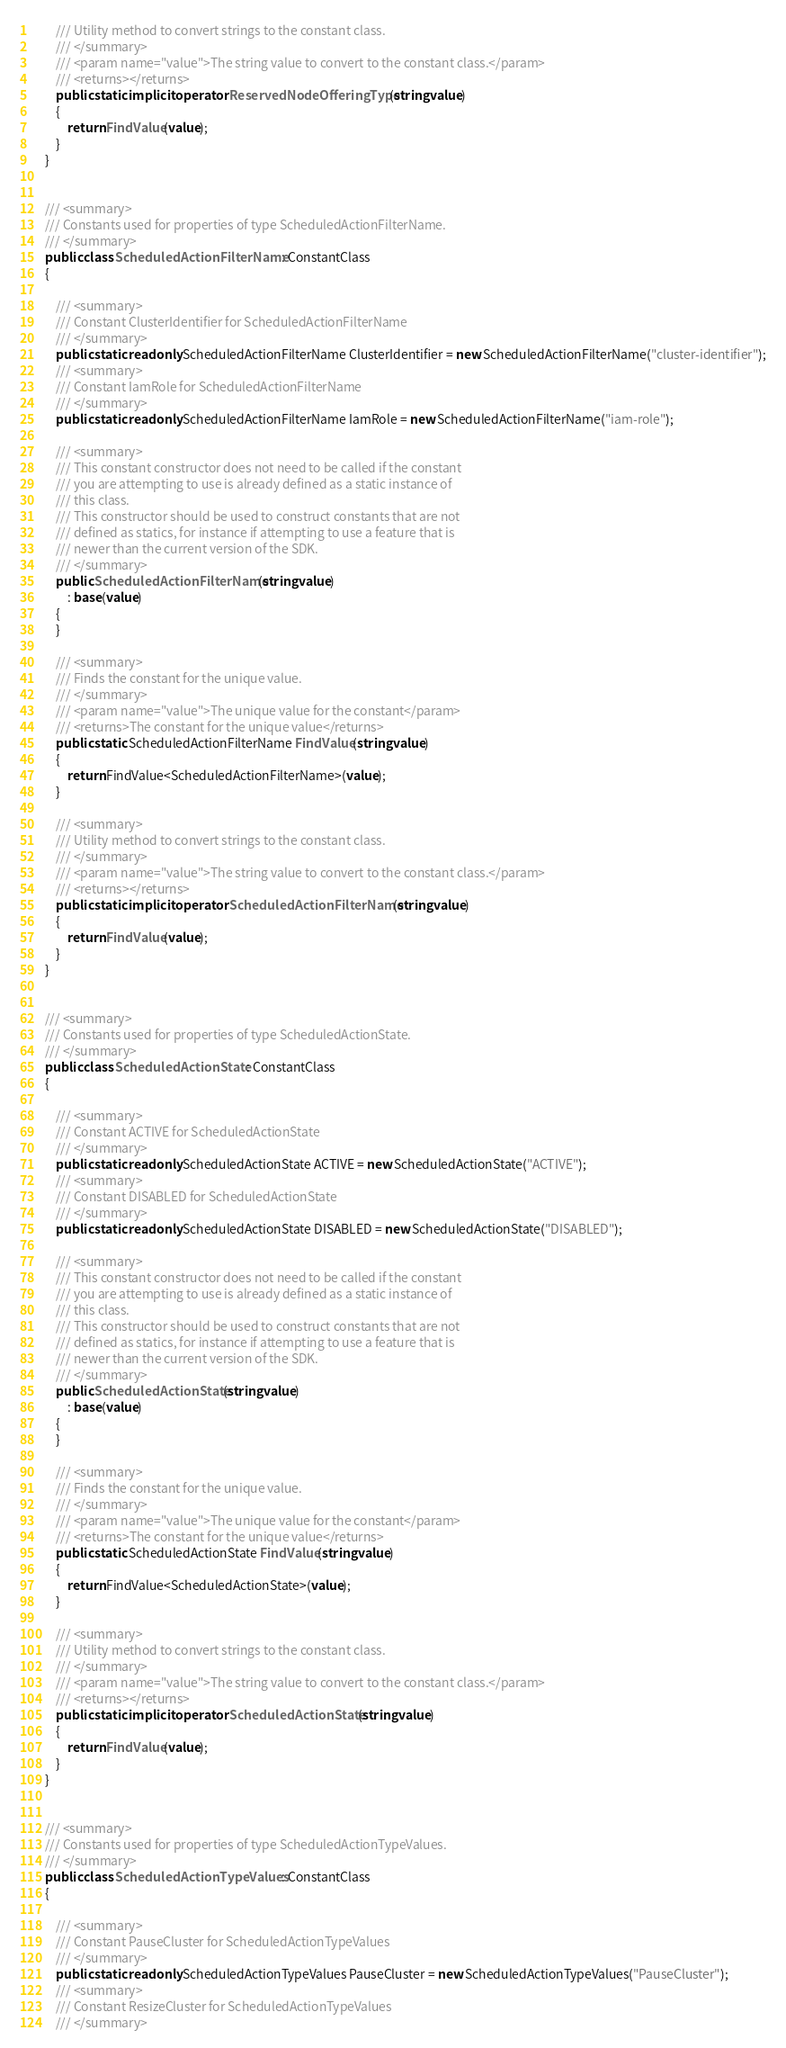<code> <loc_0><loc_0><loc_500><loc_500><_C#_>        /// Utility method to convert strings to the constant class.
        /// </summary>
        /// <param name="value">The string value to convert to the constant class.</param>
        /// <returns></returns>
        public static implicit operator ReservedNodeOfferingType(string value)
        {
            return FindValue(value);
        }
    }


    /// <summary>
    /// Constants used for properties of type ScheduledActionFilterName.
    /// </summary>
    public class ScheduledActionFilterName : ConstantClass
    {

        /// <summary>
        /// Constant ClusterIdentifier for ScheduledActionFilterName
        /// </summary>
        public static readonly ScheduledActionFilterName ClusterIdentifier = new ScheduledActionFilterName("cluster-identifier");
        /// <summary>
        /// Constant IamRole for ScheduledActionFilterName
        /// </summary>
        public static readonly ScheduledActionFilterName IamRole = new ScheduledActionFilterName("iam-role");

        /// <summary>
        /// This constant constructor does not need to be called if the constant
        /// you are attempting to use is already defined as a static instance of 
        /// this class.
        /// This constructor should be used to construct constants that are not
        /// defined as statics, for instance if attempting to use a feature that is
        /// newer than the current version of the SDK.
        /// </summary>
        public ScheduledActionFilterName(string value)
            : base(value)
        {
        }

        /// <summary>
        /// Finds the constant for the unique value.
        /// </summary>
        /// <param name="value">The unique value for the constant</param>
        /// <returns>The constant for the unique value</returns>
        public static ScheduledActionFilterName FindValue(string value)
        {
            return FindValue<ScheduledActionFilterName>(value);
        }

        /// <summary>
        /// Utility method to convert strings to the constant class.
        /// </summary>
        /// <param name="value">The string value to convert to the constant class.</param>
        /// <returns></returns>
        public static implicit operator ScheduledActionFilterName(string value)
        {
            return FindValue(value);
        }
    }


    /// <summary>
    /// Constants used for properties of type ScheduledActionState.
    /// </summary>
    public class ScheduledActionState : ConstantClass
    {

        /// <summary>
        /// Constant ACTIVE for ScheduledActionState
        /// </summary>
        public static readonly ScheduledActionState ACTIVE = new ScheduledActionState("ACTIVE");
        /// <summary>
        /// Constant DISABLED for ScheduledActionState
        /// </summary>
        public static readonly ScheduledActionState DISABLED = new ScheduledActionState("DISABLED");

        /// <summary>
        /// This constant constructor does not need to be called if the constant
        /// you are attempting to use is already defined as a static instance of 
        /// this class.
        /// This constructor should be used to construct constants that are not
        /// defined as statics, for instance if attempting to use a feature that is
        /// newer than the current version of the SDK.
        /// </summary>
        public ScheduledActionState(string value)
            : base(value)
        {
        }

        /// <summary>
        /// Finds the constant for the unique value.
        /// </summary>
        /// <param name="value">The unique value for the constant</param>
        /// <returns>The constant for the unique value</returns>
        public static ScheduledActionState FindValue(string value)
        {
            return FindValue<ScheduledActionState>(value);
        }

        /// <summary>
        /// Utility method to convert strings to the constant class.
        /// </summary>
        /// <param name="value">The string value to convert to the constant class.</param>
        /// <returns></returns>
        public static implicit operator ScheduledActionState(string value)
        {
            return FindValue(value);
        }
    }


    /// <summary>
    /// Constants used for properties of type ScheduledActionTypeValues.
    /// </summary>
    public class ScheduledActionTypeValues : ConstantClass
    {

        /// <summary>
        /// Constant PauseCluster for ScheduledActionTypeValues
        /// </summary>
        public static readonly ScheduledActionTypeValues PauseCluster = new ScheduledActionTypeValues("PauseCluster");
        /// <summary>
        /// Constant ResizeCluster for ScheduledActionTypeValues
        /// </summary></code> 